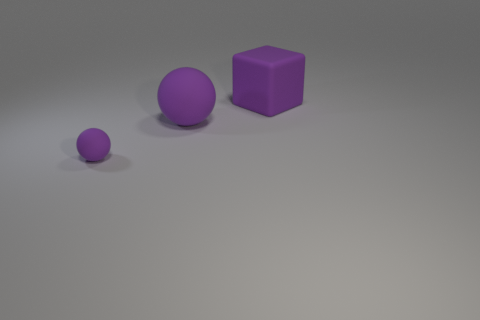What size is the purple rubber ball that is behind the purple thing that is in front of the purple sphere behind the tiny thing?
Your response must be concise. Large. There is a small rubber sphere; are there any small purple rubber balls behind it?
Your response must be concise. No. What is the shape of the big matte thing that is the same color as the cube?
Give a very brief answer. Sphere. How many objects are either purple rubber objects behind the tiny purple matte sphere or gray cubes?
Offer a very short reply. 2. There is a purple cube that is made of the same material as the large ball; what is its size?
Ensure brevity in your answer.  Large. There is a purple matte cube; does it have the same size as the purple matte sphere that is on the right side of the tiny purple ball?
Your response must be concise. Yes. There is a rubber object that is right of the tiny rubber thing and left of the purple block; what color is it?
Offer a terse response. Purple. How many objects are either objects in front of the large purple matte block or things on the right side of the large purple rubber sphere?
Make the answer very short. 3. The matte cube behind the purple object to the left of the rubber sphere to the right of the tiny matte object is what color?
Your answer should be very brief. Purple. Is there a large matte object of the same shape as the tiny purple thing?
Your answer should be very brief. Yes. 